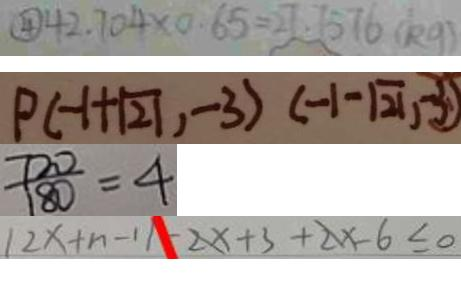Convert formula to latex. <formula><loc_0><loc_0><loc_500><loc_500>\textcircled { 4 } 4 2 . 7 0 4 \times 0 . 6 5 = 2 7 . 7 5 7 6 ( k g ) 
 P ( - 1 + \sqrt { 2 1 } , - 3 ) ( - 1 - \sqrt { 2 1 } , - 3 ) 
 \frac { 7 2 0 } { 1 8 0 } = 4 
 1 2 x + n - 1 1 - 2 x + 3 + 2 x - 6 \leq 0</formula> 